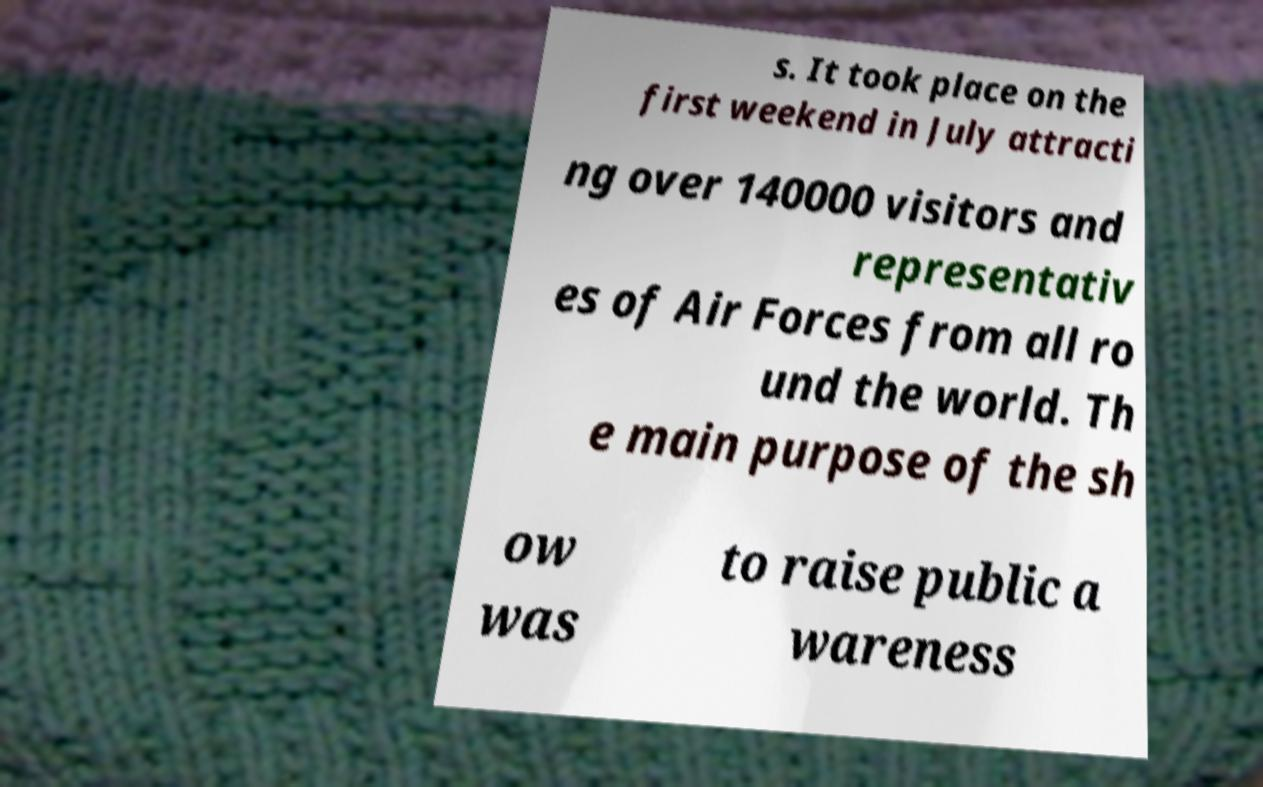What messages or text are displayed in this image? I need them in a readable, typed format. s. It took place on the first weekend in July attracti ng over 140000 visitors and representativ es of Air Forces from all ro und the world. Th e main purpose of the sh ow was to raise public a wareness 